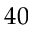<formula> <loc_0><loc_0><loc_500><loc_500>4 0</formula> 